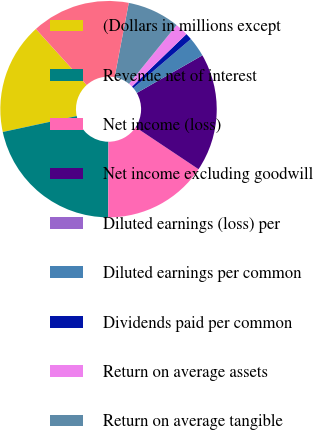Convert chart to OTSL. <chart><loc_0><loc_0><loc_500><loc_500><pie_chart><fcel>(Dollars in millions except<fcel>Revenue net of interest<fcel>Net income (loss)<fcel>Net income excluding goodwill<fcel>Diluted earnings (loss) per<fcel>Diluted earnings per common<fcel>Dividends paid per common<fcel>Return on average assets<fcel>Return on average tangible<fcel>Efficiency ratio (FTE basis)<nl><fcel>16.67%<fcel>21.57%<fcel>15.69%<fcel>17.65%<fcel>0.0%<fcel>2.94%<fcel>0.98%<fcel>1.96%<fcel>7.84%<fcel>14.71%<nl></chart> 